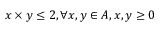<formula> <loc_0><loc_0><loc_500><loc_500>x \times y \leq 2 , \forall x , y \in A , x , y \geq 0</formula> 